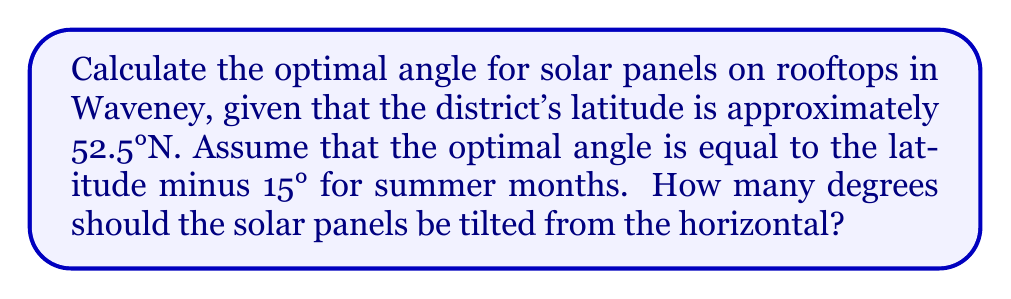Teach me how to tackle this problem. To determine the optimal angle for solar panels in Waveney, we'll follow these steps:

1. Identify Waveney's latitude:
   Waveney is located at approximately 52.5°N latitude.

2. Apply the rule for optimal summer angle:
   The optimal angle for summer months is given by the formula:
   $$\text{Optimal Angle} = \text{Latitude} - 15°$$

3. Calculate the optimal angle:
   $$\begin{align}
   \text{Optimal Angle} &= 52.5° - 15° \\
   &= 37.5°
   \end{align}$$

4. Verify the result:
   The calculated angle of 37.5° represents the tilt from the horizontal plane. This means the solar panels should be oriented facing south and tilted upwards at this angle for optimal performance during summer months in Waveney.

[asy]
import geometry;

size(200);
draw((-3,0)--(3,0),arrow=Arrow(TeXHead));
draw((0,0)--(0,3),arrow=Arrow(TeXHead));
draw((0,0)--(2,1.5),linewidth(1));
draw(arc((0,0),0.5,0,37.5),arrow=Arrow(TeXHead));

label("Horizontal", (3,-0.2), E);
label("Vertical", (-0.2,3), N);
label("Solar Panel", (1,1), NE);
label("37.5°", (0.6,0.2), NE);
[/asy]
Answer: 37.5° 